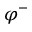Convert formula to latex. <formula><loc_0><loc_0><loc_500><loc_500>\varphi ^ { - }</formula> 